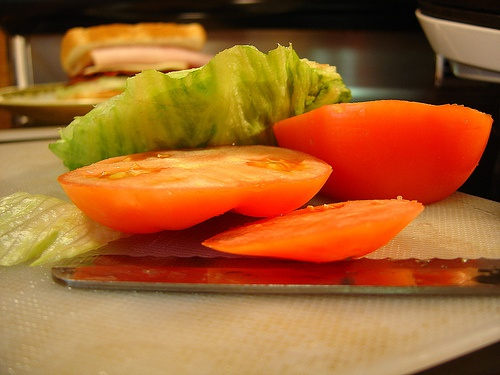Describe the objects in this image and their specific colors. I can see dining table in black, tan, and red tones, knife in black, maroon, olive, and brown tones, dining table in black, maroon, olive, and gray tones, and sandwich in black, orange, and red tones in this image. 